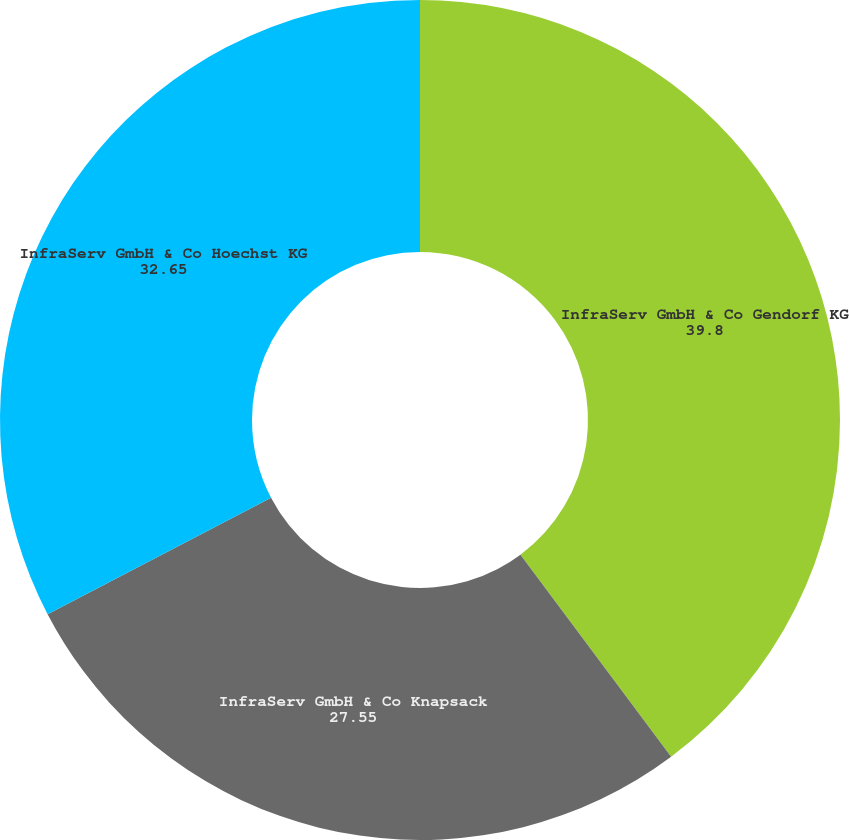<chart> <loc_0><loc_0><loc_500><loc_500><pie_chart><fcel>InfraServ GmbH & Co Gendorf KG<fcel>InfraServ GmbH & Co Knapsack<fcel>InfraServ GmbH & Co Hoechst KG<nl><fcel>39.8%<fcel>27.55%<fcel>32.65%<nl></chart> 